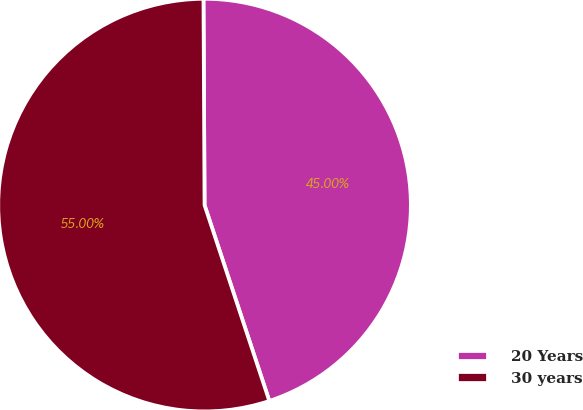Convert chart. <chart><loc_0><loc_0><loc_500><loc_500><pie_chart><fcel>20 Years<fcel>30 years<nl><fcel>45.0%<fcel>55.0%<nl></chart> 